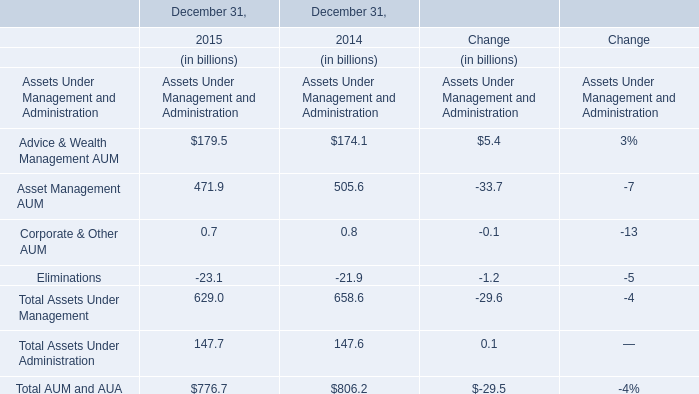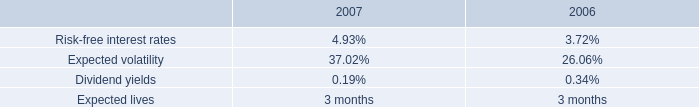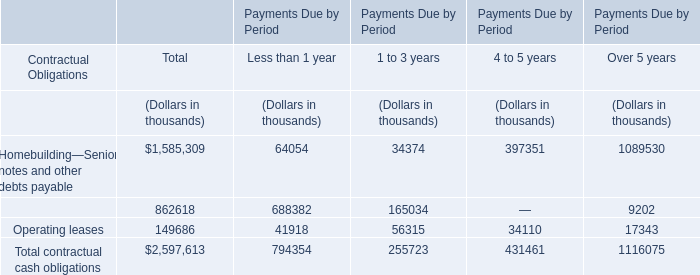in 2008 , how much of the compensation will be used on stock purchases if the employees used 20% ( 20 % ) of their compensation? 
Computations: (5.7 * 20%)
Answer: 1.14. 